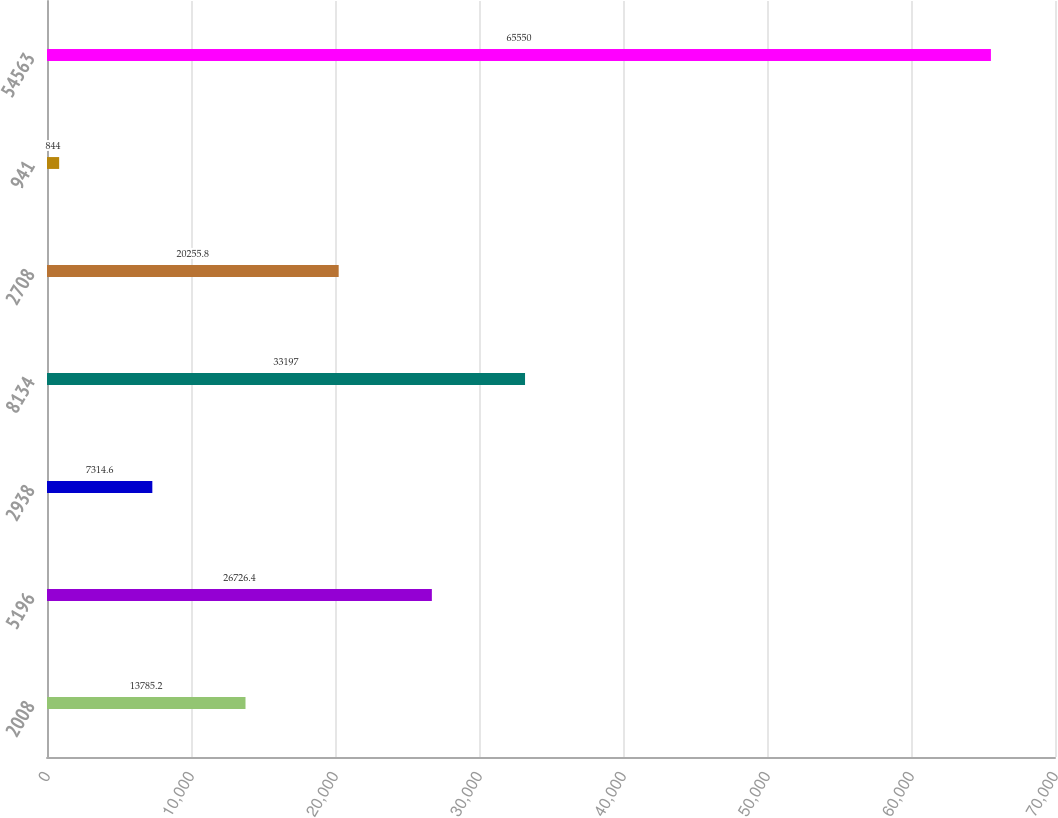Convert chart to OTSL. <chart><loc_0><loc_0><loc_500><loc_500><bar_chart><fcel>2008<fcel>5196<fcel>2938<fcel>8134<fcel>2708<fcel>941<fcel>54563<nl><fcel>13785.2<fcel>26726.4<fcel>7314.6<fcel>33197<fcel>20255.8<fcel>844<fcel>65550<nl></chart> 